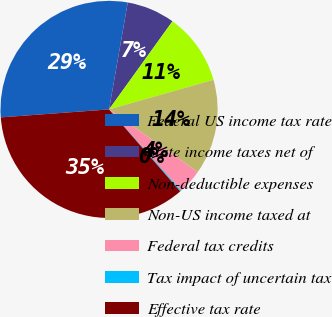Convert chart to OTSL. <chart><loc_0><loc_0><loc_500><loc_500><pie_chart><fcel>Federal US income tax rate<fcel>State income taxes net of<fcel>Non-deductible expenses<fcel>Non-US income taxed at<fcel>Federal tax credits<fcel>Tax impact of uncertain tax<fcel>Effective tax rate<nl><fcel>28.93%<fcel>7.17%<fcel>10.68%<fcel>14.18%<fcel>3.67%<fcel>0.17%<fcel>35.21%<nl></chart> 